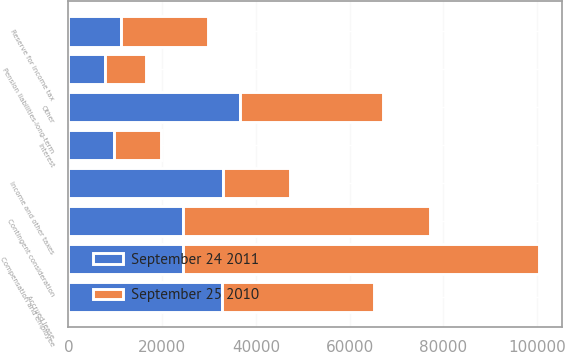Convert chart. <chart><loc_0><loc_0><loc_500><loc_500><stacked_bar_chart><ecel><fcel>Compensation and employee<fcel>Contingent consideration<fcel>Income and other taxes<fcel>Interest<fcel>Other<fcel>Accrued lease<fcel>Reserve for income tax<fcel>Pension liabilities-long-term<nl><fcel>September 24 2011<fcel>24541.5<fcel>24541.5<fcel>33070<fcel>9802<fcel>36504<fcel>32846<fcel>11202<fcel>7714<nl><fcel>September 25 2010<fcel>75772<fcel>52562<fcel>14278<fcel>9892<fcel>30550<fcel>32326<fcel>18533<fcel>8756<nl></chart> 